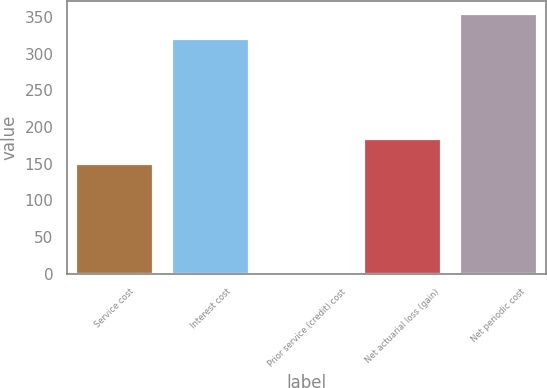Convert chart. <chart><loc_0><loc_0><loc_500><loc_500><bar_chart><fcel>Service cost<fcel>Interest cost<fcel>Prior service (credit) cost<fcel>Net actuarial loss (gain)<fcel>Net periodic cost<nl><fcel>150<fcel>320<fcel>2<fcel>184.3<fcel>354.3<nl></chart> 